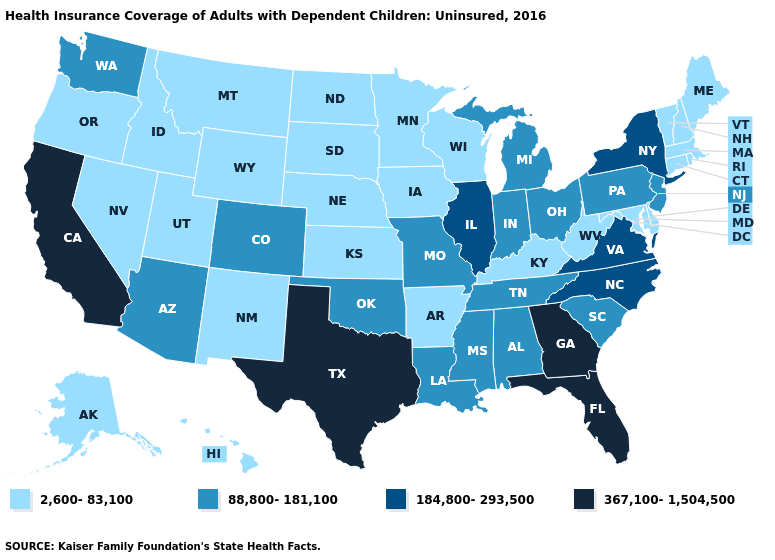Among the states that border Idaho , does Nevada have the highest value?
Short answer required. No. What is the value of Minnesota?
Write a very short answer. 2,600-83,100. Name the states that have a value in the range 184,800-293,500?
Quick response, please. Illinois, New York, North Carolina, Virginia. Name the states that have a value in the range 88,800-181,100?
Concise answer only. Alabama, Arizona, Colorado, Indiana, Louisiana, Michigan, Mississippi, Missouri, New Jersey, Ohio, Oklahoma, Pennsylvania, South Carolina, Tennessee, Washington. Name the states that have a value in the range 88,800-181,100?
Short answer required. Alabama, Arizona, Colorado, Indiana, Louisiana, Michigan, Mississippi, Missouri, New Jersey, Ohio, Oklahoma, Pennsylvania, South Carolina, Tennessee, Washington. Does the map have missing data?
Keep it brief. No. Does South Dakota have a lower value than New Hampshire?
Short answer required. No. Name the states that have a value in the range 88,800-181,100?
Write a very short answer. Alabama, Arizona, Colorado, Indiana, Louisiana, Michigan, Mississippi, Missouri, New Jersey, Ohio, Oklahoma, Pennsylvania, South Carolina, Tennessee, Washington. Which states have the highest value in the USA?
Be succinct. California, Florida, Georgia, Texas. Which states have the lowest value in the USA?
Answer briefly. Alaska, Arkansas, Connecticut, Delaware, Hawaii, Idaho, Iowa, Kansas, Kentucky, Maine, Maryland, Massachusetts, Minnesota, Montana, Nebraska, Nevada, New Hampshire, New Mexico, North Dakota, Oregon, Rhode Island, South Dakota, Utah, Vermont, West Virginia, Wisconsin, Wyoming. Name the states that have a value in the range 2,600-83,100?
Quick response, please. Alaska, Arkansas, Connecticut, Delaware, Hawaii, Idaho, Iowa, Kansas, Kentucky, Maine, Maryland, Massachusetts, Minnesota, Montana, Nebraska, Nevada, New Hampshire, New Mexico, North Dakota, Oregon, Rhode Island, South Dakota, Utah, Vermont, West Virginia, Wisconsin, Wyoming. What is the value of New Mexico?
Quick response, please. 2,600-83,100. Name the states that have a value in the range 184,800-293,500?
Write a very short answer. Illinois, New York, North Carolina, Virginia. What is the value of Utah?
Quick response, please. 2,600-83,100. What is the value of Montana?
Answer briefly. 2,600-83,100. 